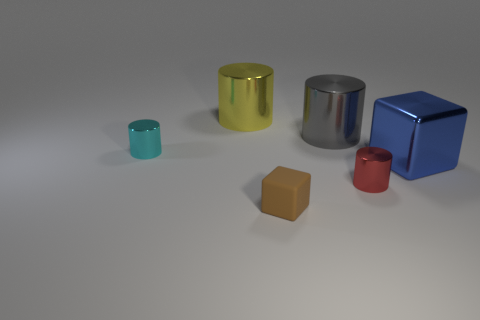Add 3 large gray cubes. How many objects exist? 9 Subtract all blocks. How many objects are left? 4 Add 1 yellow metal things. How many yellow metal things are left? 2 Add 3 big brown rubber cubes. How many big brown rubber cubes exist? 3 Subtract 0 cyan cubes. How many objects are left? 6 Subtract all cyan shiny cylinders. Subtract all small blue rubber balls. How many objects are left? 5 